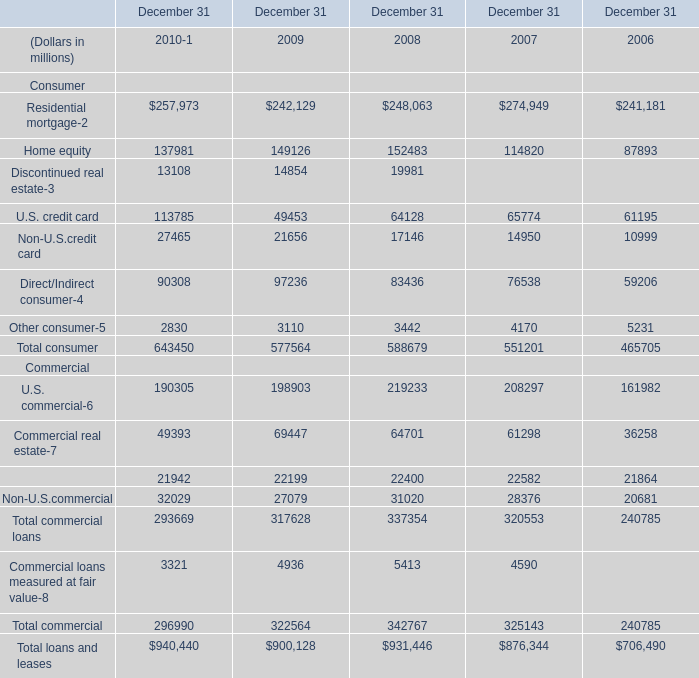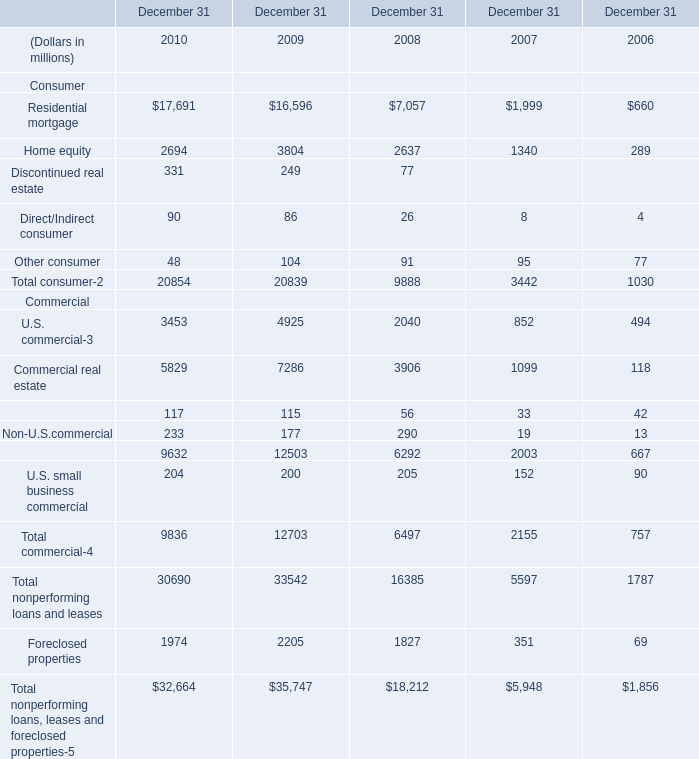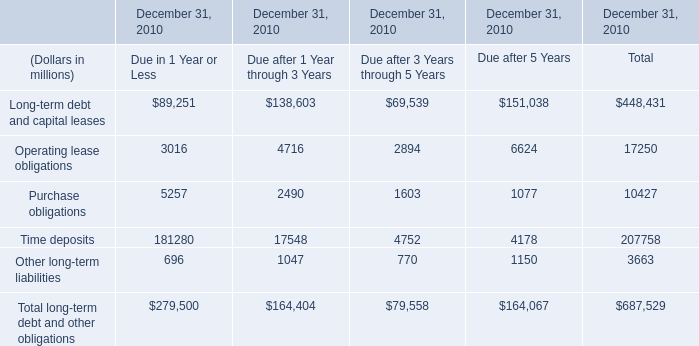What will Home equity reach in 2011 if it continues to grow at its current rate? (in millions) 
Computations: (exp((1 + ((137981 - 149126) / 149126)) * 2))
Answer: 118127.5309. 